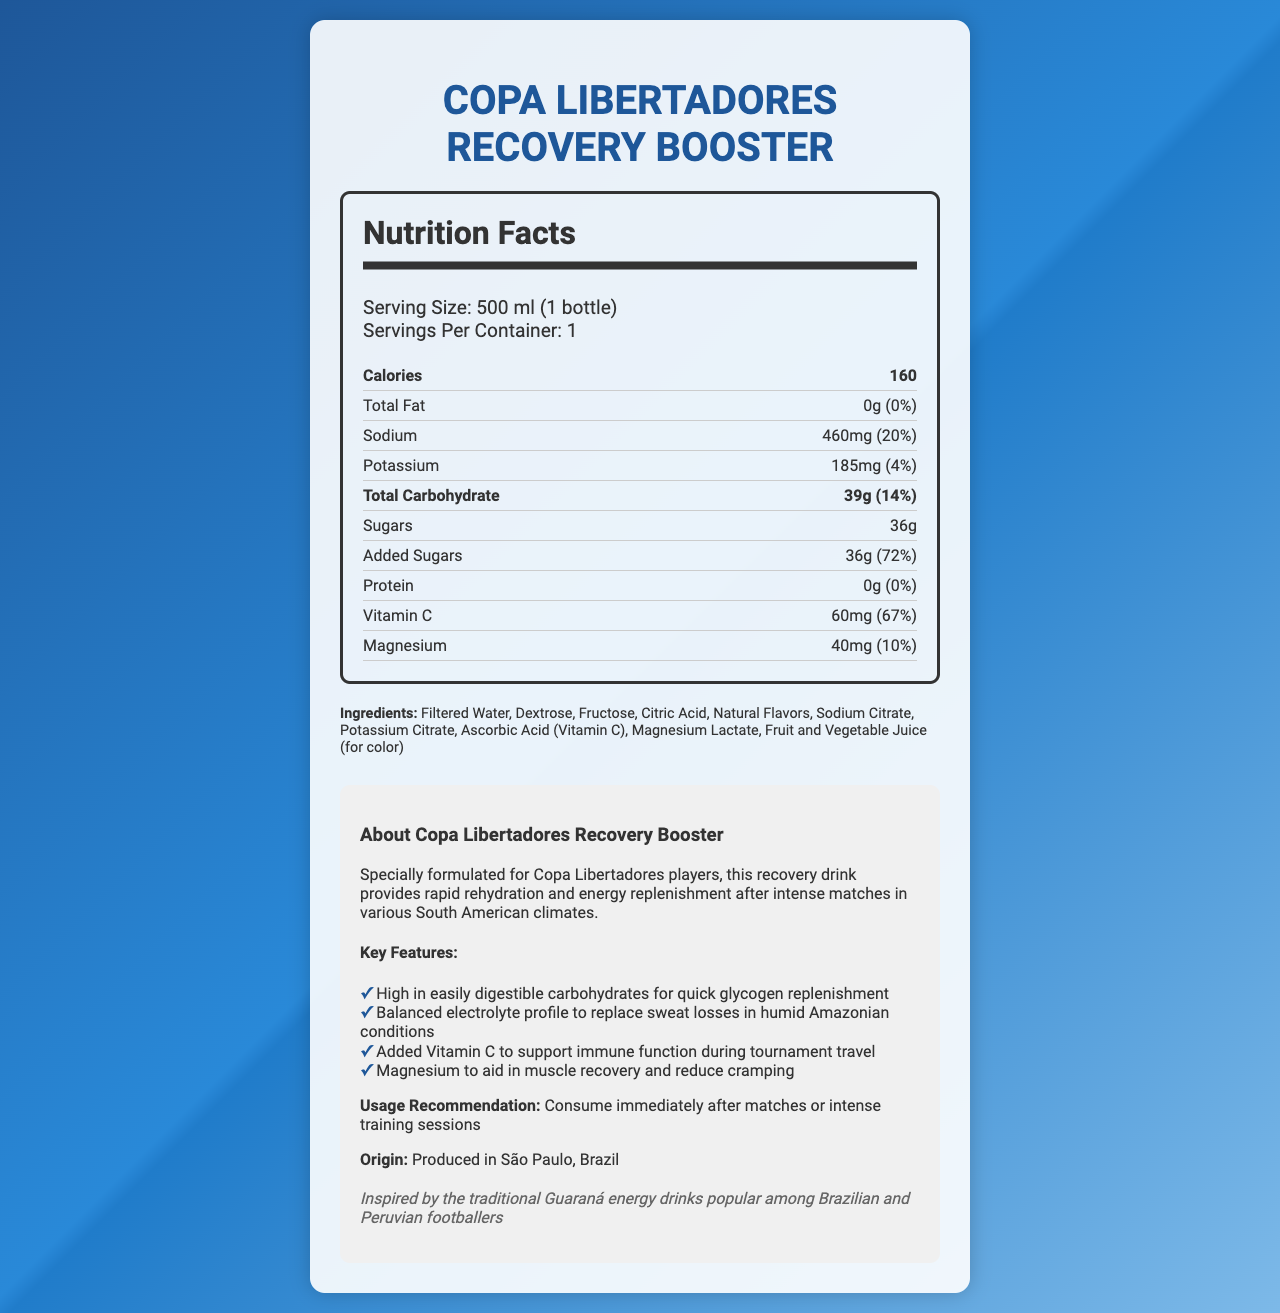what is the serving size? The serving size is clearly stated at the beginning of the Nutrition Facts Label.
Answer: 500 ml (1 bottle) how many grams of total carbohydrates are in one serving? The label indicates that one serving has 39 grams of total carbohydrates.
Answer: 39g how much sodium does one bottle contain? The amount of sodium per serving is listed as 460mg on the Nutrition Facts Label.
Answer: 460mg what percentage of daily value is provided by added sugars? The label mentions that the daily value for added sugars is 72%.
Answer: 72% what is the main idea of this document? The document includes detailed nutritional information, ingredients, key features, usage recommendations, and some additional context about the product.
Answer: The document provides the nutritional analysis for Copa Libertadores Recovery Booster, a recovery drink formulated for players, highlighting its carbohydrate and electrolyte content, along with additional benefits such as Vitamin C and magnesium. how much protein is in the recovery drink? The Nutrition Facts label lists protein content as 0g.
Answer: 0g what is the origin of this recovery drink? The additional info section states that the drink is produced in São Paulo, Brazil.
Answer: Produced in São Paulo, Brazil which electrolytes are highlighted in the document? A. Sodium and Chlorine B. Potassium and Phosphorus C. Sodium and Potassium The nutrients sodium (460mg) and potassium (185mg) are specifically highlighted in the document.
Answer: C. Sodium and Potassium how many calories does the recovery drink provide? The Nutrition Facts label states that there are 160 calories per serving.
Answer: 160 is there any fat in the recovery drink? The label indicates that the total fat content is 0g, which means there is no fat in the drink.
Answer: No which of the following key features is NOT mentioned for the recovery drink? 1. High in easily digestible carbohydrates 2. Contains high levels of protein 3. Balanced electrolyte profile The document does not mention high levels of protein. It specifically states that the protein content is 0g.
Answer: 2. Contains high levels of protein what are the two main types of sugars in the ingredients? The ingredients list mentions Dextrose and Fructose as the types of sugars contained in the drink.
Answer: Dextrose and Fructose is this recovery drink inspired by traditional Guaraná energy drinks? The fun fact in the additional info section states that the drink is inspired by traditional Guaraná energy drinks popular among Brazilian and Peruvian footballers.
Answer: Yes what is the fun fact mentioned in the document? The fun fact is provided in the additional info section.
Answer: Inspired by the traditional Guaraná energy drinks popular among Brazilian and Peruvian footballers what's the percentage of daily value of magnesium in the drink? The Nutrition Facts label lists the daily value of magnesium as 10%.
Answer: 10% how much Vitamin C does the recovery drink contain? The amount of Vitamin C is listed as 60mg in the Nutrition Facts label.
Answer: 60mg what is the main purpose of this recovery drink? The additional info section describes the drink's purpose as helping Copa Libertadores players quickly rehydrate and replenish energy after intense matches.
Answer: To provide rapid rehydration and energy replenishment after intense matches. how many servings per container does the drink have? The Nutrition Facts label clearly states there is one serving per container.
Answer: 1 is it clear from the document how long the drink should be consumed after matches? The label advises consuming the drink immediately after matches or intense training, but does not specify a precise time period.
Answer: No what additional benefit does Vitamin C provide in the drink? The additional information section highlights that Vitamin C is added to support immune function during tournament travel.
Answer: Supports immune function during tournament travel 